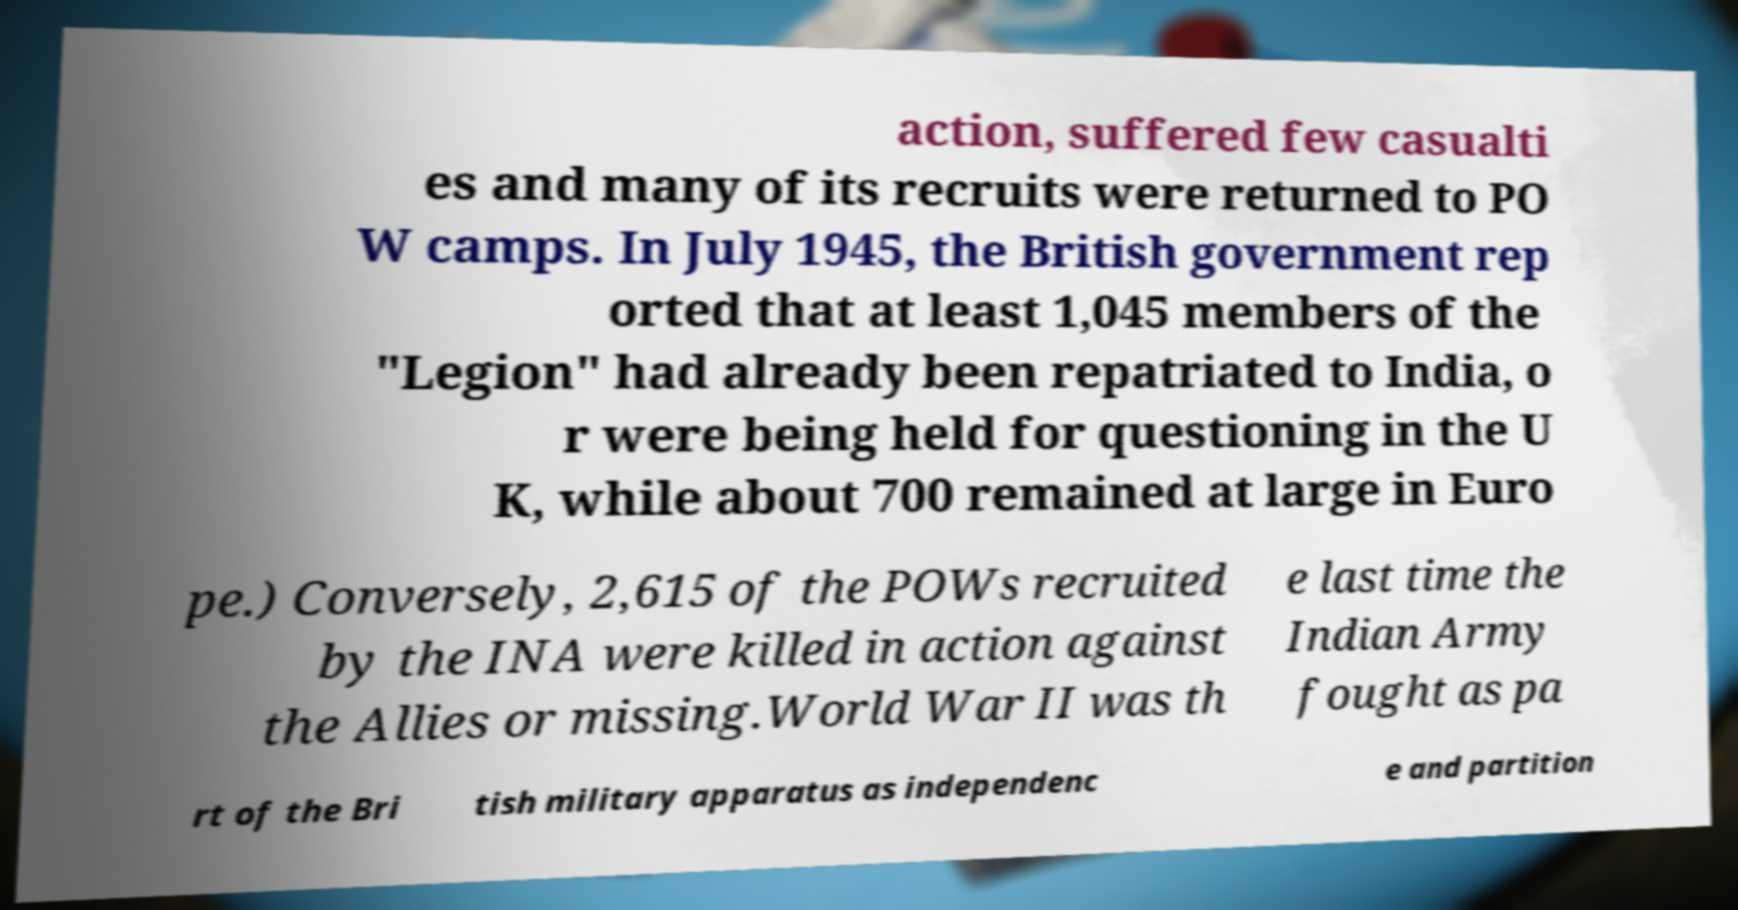Please read and relay the text visible in this image. What does it say? action, suffered few casualti es and many of its recruits were returned to PO W camps. In July 1945, the British government rep orted that at least 1,045 members of the "Legion" had already been repatriated to India, o r were being held for questioning in the U K, while about 700 remained at large in Euro pe.) Conversely, 2,615 of the POWs recruited by the INA were killed in action against the Allies or missing.World War II was th e last time the Indian Army fought as pa rt of the Bri tish military apparatus as independenc e and partition 